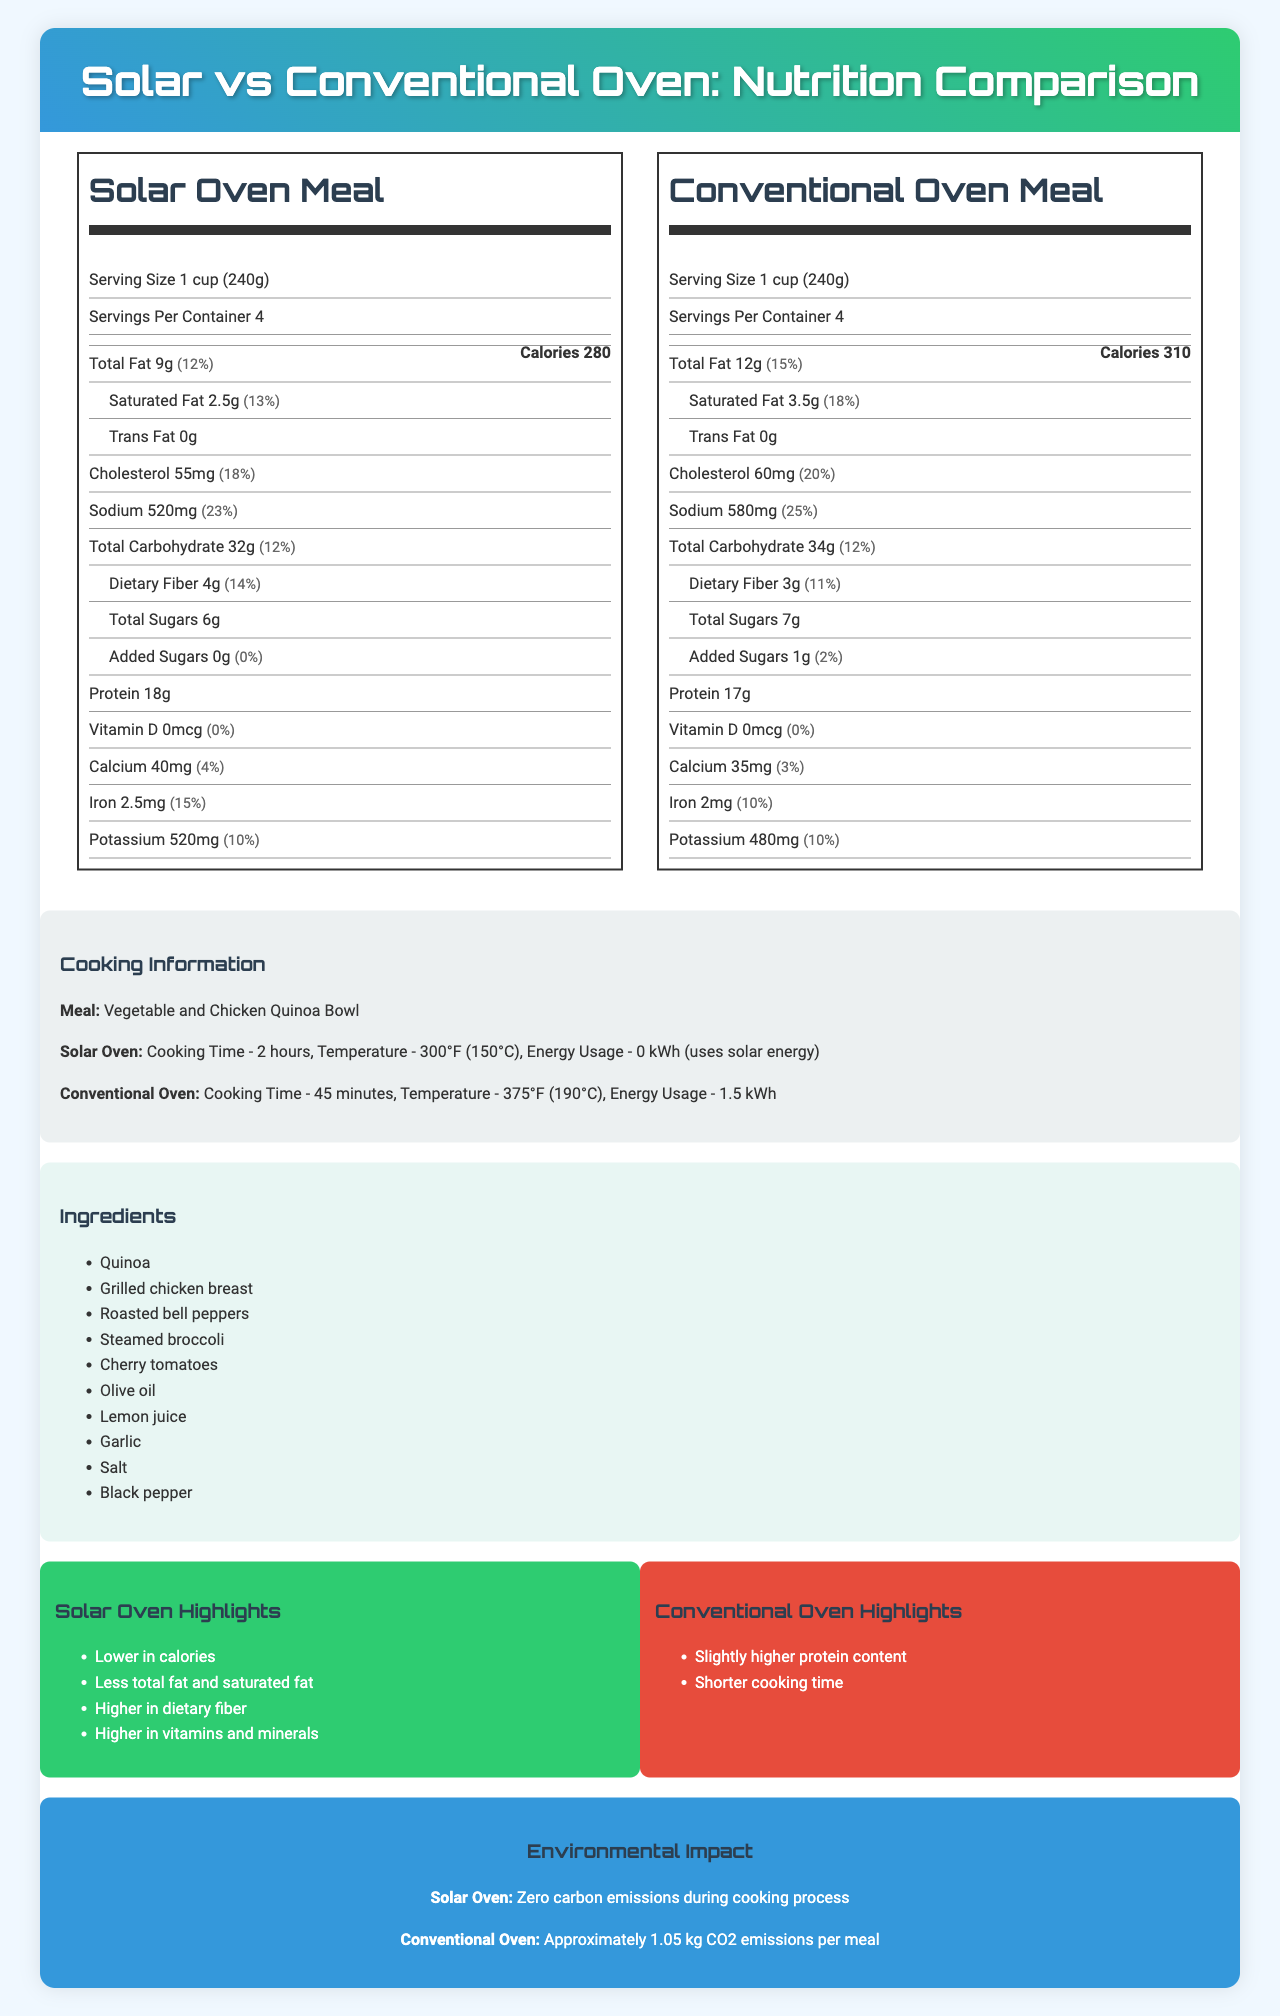what is the serving size for the solar oven meal? The serving size for the solar oven meal is listed at the top of the nutrition label under "Solar Oven Meal" as "1 cup (240g)".
Answer: 1 cup (240g) what is the calorie difference between the meals cooked in the solar oven and the conventional oven? The calorie count for the solar oven meal is 280 calories, while the conventional oven meal is 310 calories, making a difference of 30 calories.
Answer: 30 calories how much protein is in the conventional oven meal? The amount of protein in the conventional oven meal is listed under the section "Protein" as "17g".
Answer: 17g which meal has a higher amount of dietary fiber? The solar oven meal has 4g of dietary fiber, while the conventional oven meal has 3g of dietary fiber.
Answer: Solar oven meal does the solar oven meal contain any added sugars? The solar oven meal lists "0g" for added sugars with a daily value of "0%".
Answer: No which meal has more vitamin C? A. Solar oven meal B. Conventional oven meal C. Both are equal The solar oven meal contains 15mg of vitamin C, while the conventional oven meal contains 12mg.
Answer: A how much sodium does the conventional oven meal contain? A. 480mg B. 520mg C. 580mg D. 640mg The conventional oven meal contains 580mg of sodium.
Answer: C which of the following statements is true? A. The conventional oven meal is lower in calories B. The solar oven meal has less total fat C. Both meals have the same protein content D. The conventional oven meal has more dietary fiber The solar oven meal has 9g of total fat, while the conventional oven meal has 12g.
Answer: B is there any cholesterol in the solar oven meal? The solar oven meal contains 55mg of cholesterol.
Answer: Yes was a controlled laboratory used to measure the nutritional content? The document does not provide information on the conditions under which the nutritional content was measured.
Answer: Cannot be determined describe the main idea of the document. The document aims to provide a comprehensive comparison between meals cooked in a solar oven and a conventional oven. It details the nutrition facts for both cooking methods, highlights their differences in terms of nutrients, environmental impacts, and cooking details. The overall purpose is to emphasize the benefits of solar cooking over conventional methods.
Answer: The document compares the nutritional content, cooking methods, and environmental impacts of a Vegetable and Chicken Quinoa Bowl cooked using a solar oven versus a conventional oven. The solar oven meal generally has lower calories, fat, and higher dietary fiber. The solar oven also uses renewable energy, producing zero carbon emissions. 